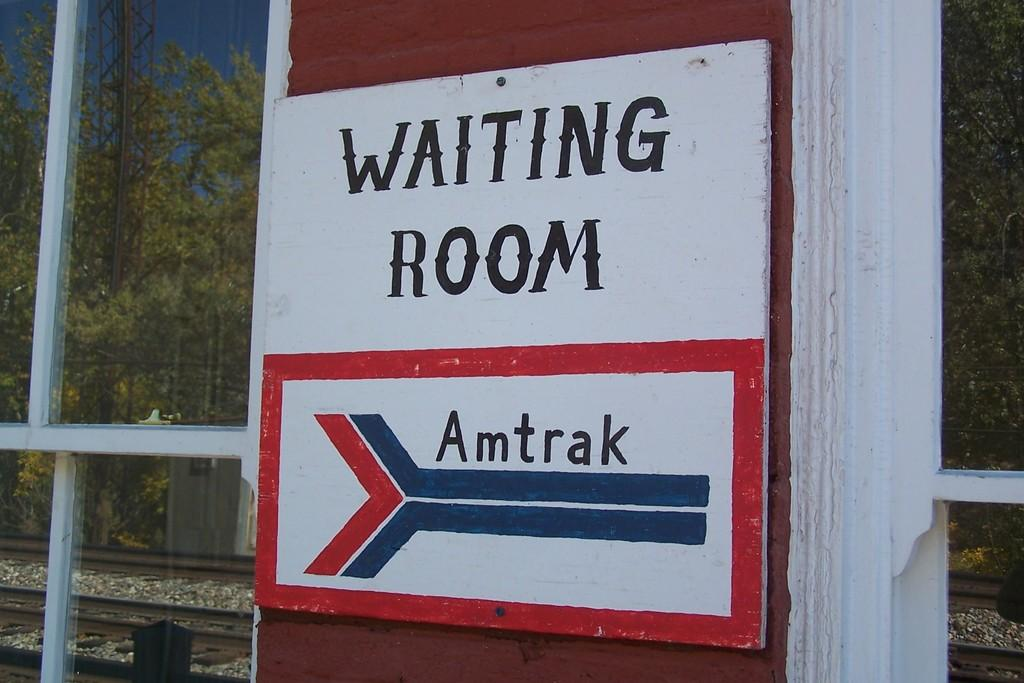What is on the board that is attached to the wall in the image? There is text on the board in the image. Where is the board located in the image? The board is attached to a wall in the image. What can be seen through the windows in the image? The reflection of a railway track, trees, and a tower is visible on the windows in the image. What type of muscle is visible in the image? There is no muscle visible in the image; the focus is on the board, wall, and windows. 